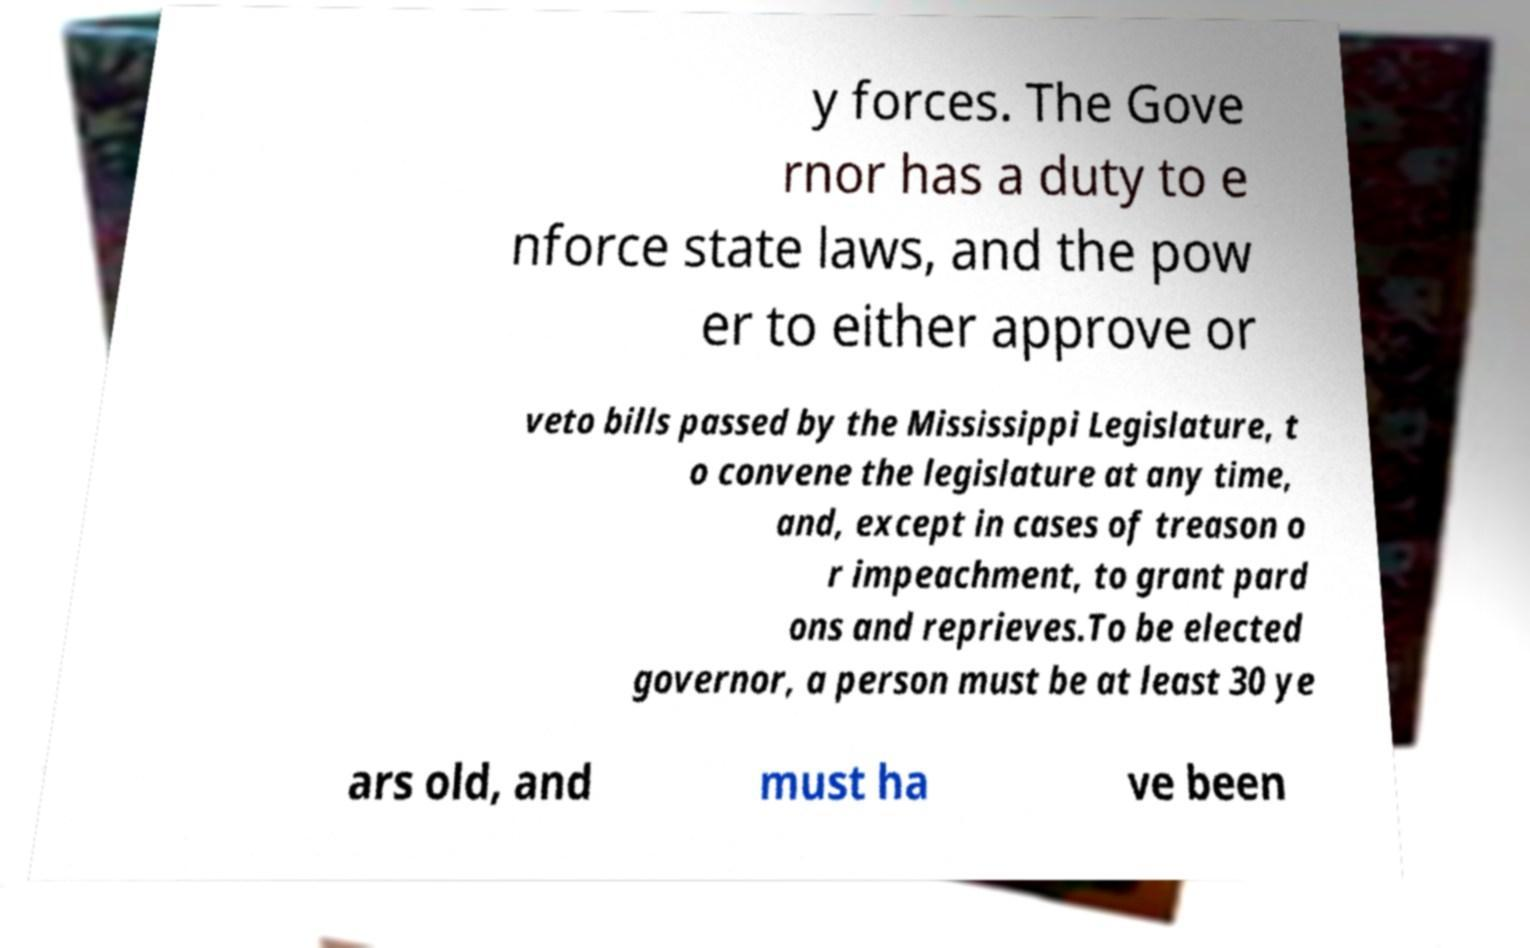Please identify and transcribe the text found in this image. y forces. The Gove rnor has a duty to e nforce state laws, and the pow er to either approve or veto bills passed by the Mississippi Legislature, t o convene the legislature at any time, and, except in cases of treason o r impeachment, to grant pard ons and reprieves.To be elected governor, a person must be at least 30 ye ars old, and must ha ve been 